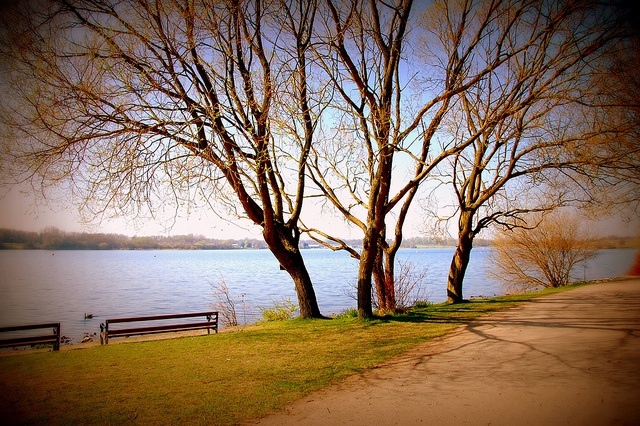Describe the objects in this image and their specific colors. I can see bench in black, darkgray, brown, and maroon tones, bench in black, maroon, and gray tones, and bird in black, brown, maroon, and gray tones in this image. 